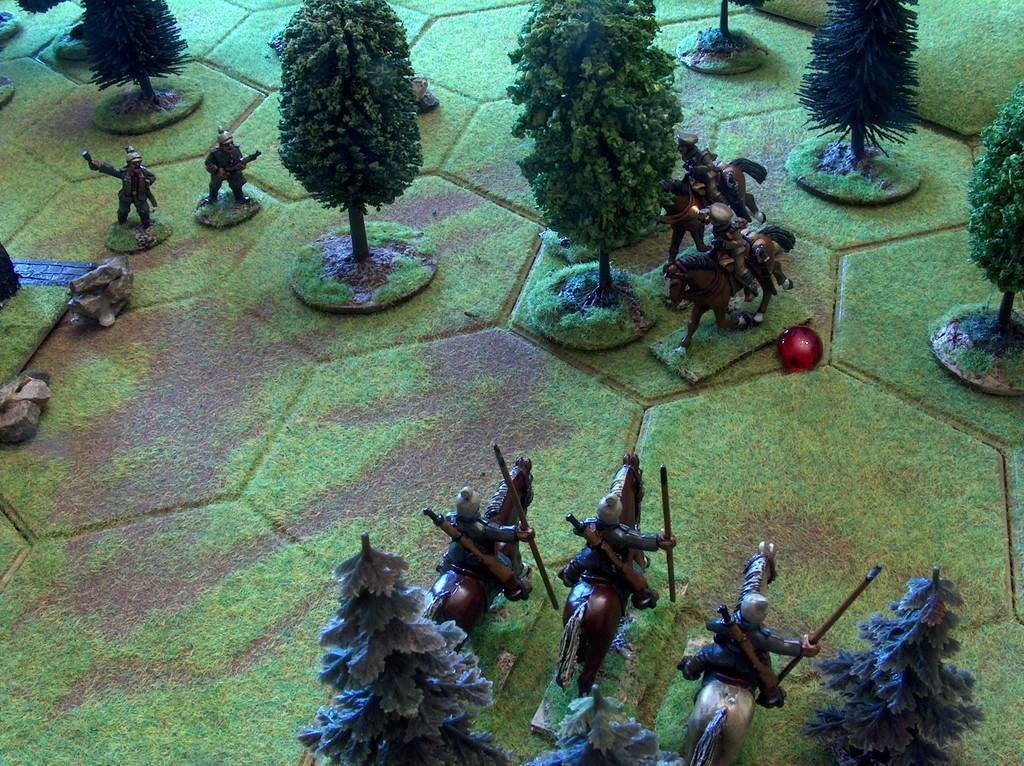Could you give a brief overview of what you see in this image? It looks like some project,there are small trees and in between the trees there are images of soldiers and horses. 